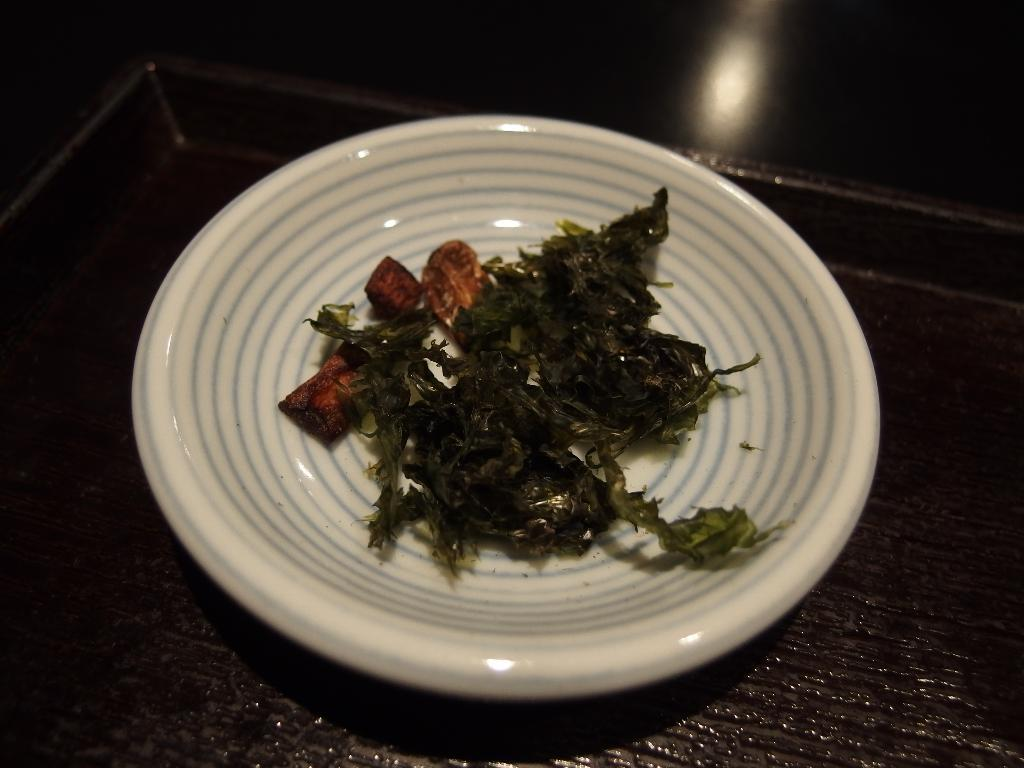What is on the plate that is visible in the image? There is food on a plate in the image. How is the plate being supported or carried? The plate is on a tray. What can be seen in the distance behind the plate? There is a tree visible in the background of the image. How would you describe the lighting in the image? The background of the image is dark with light. What grade did the cake receive in the image? There is no cake present in the image, so it cannot receive a grade. Is there a flame visible in the image? No, there is no flame visible in the image. 